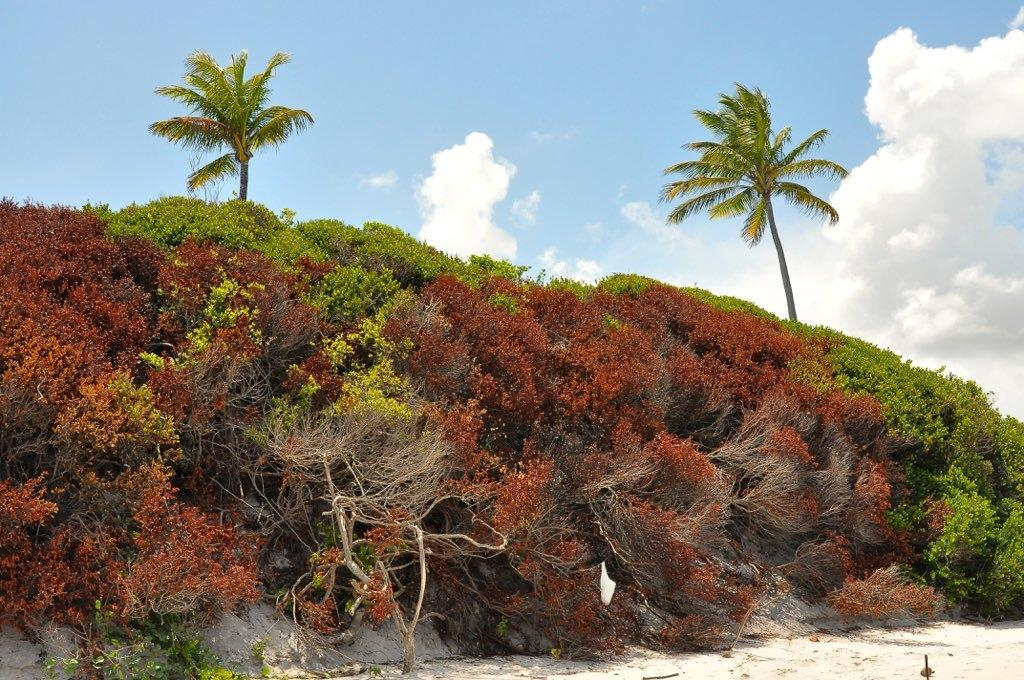What type of vegetation can be seen in the image? There are trees in the image. What geographical feature is present in the image? There is a hill in the image. What part of the natural environment is visible in the image? The sky is visible in the image. What atmospheric conditions can be observed in the sky? Clouds are present in the sky. What type of society can be seen interacting with the trees in the image? There is no society present in the image; it only features trees, a hill, and the sky. How many cherries can be seen on the hill in the image? There are no cherries present in the image; it only features trees, a hill, and the sky. 